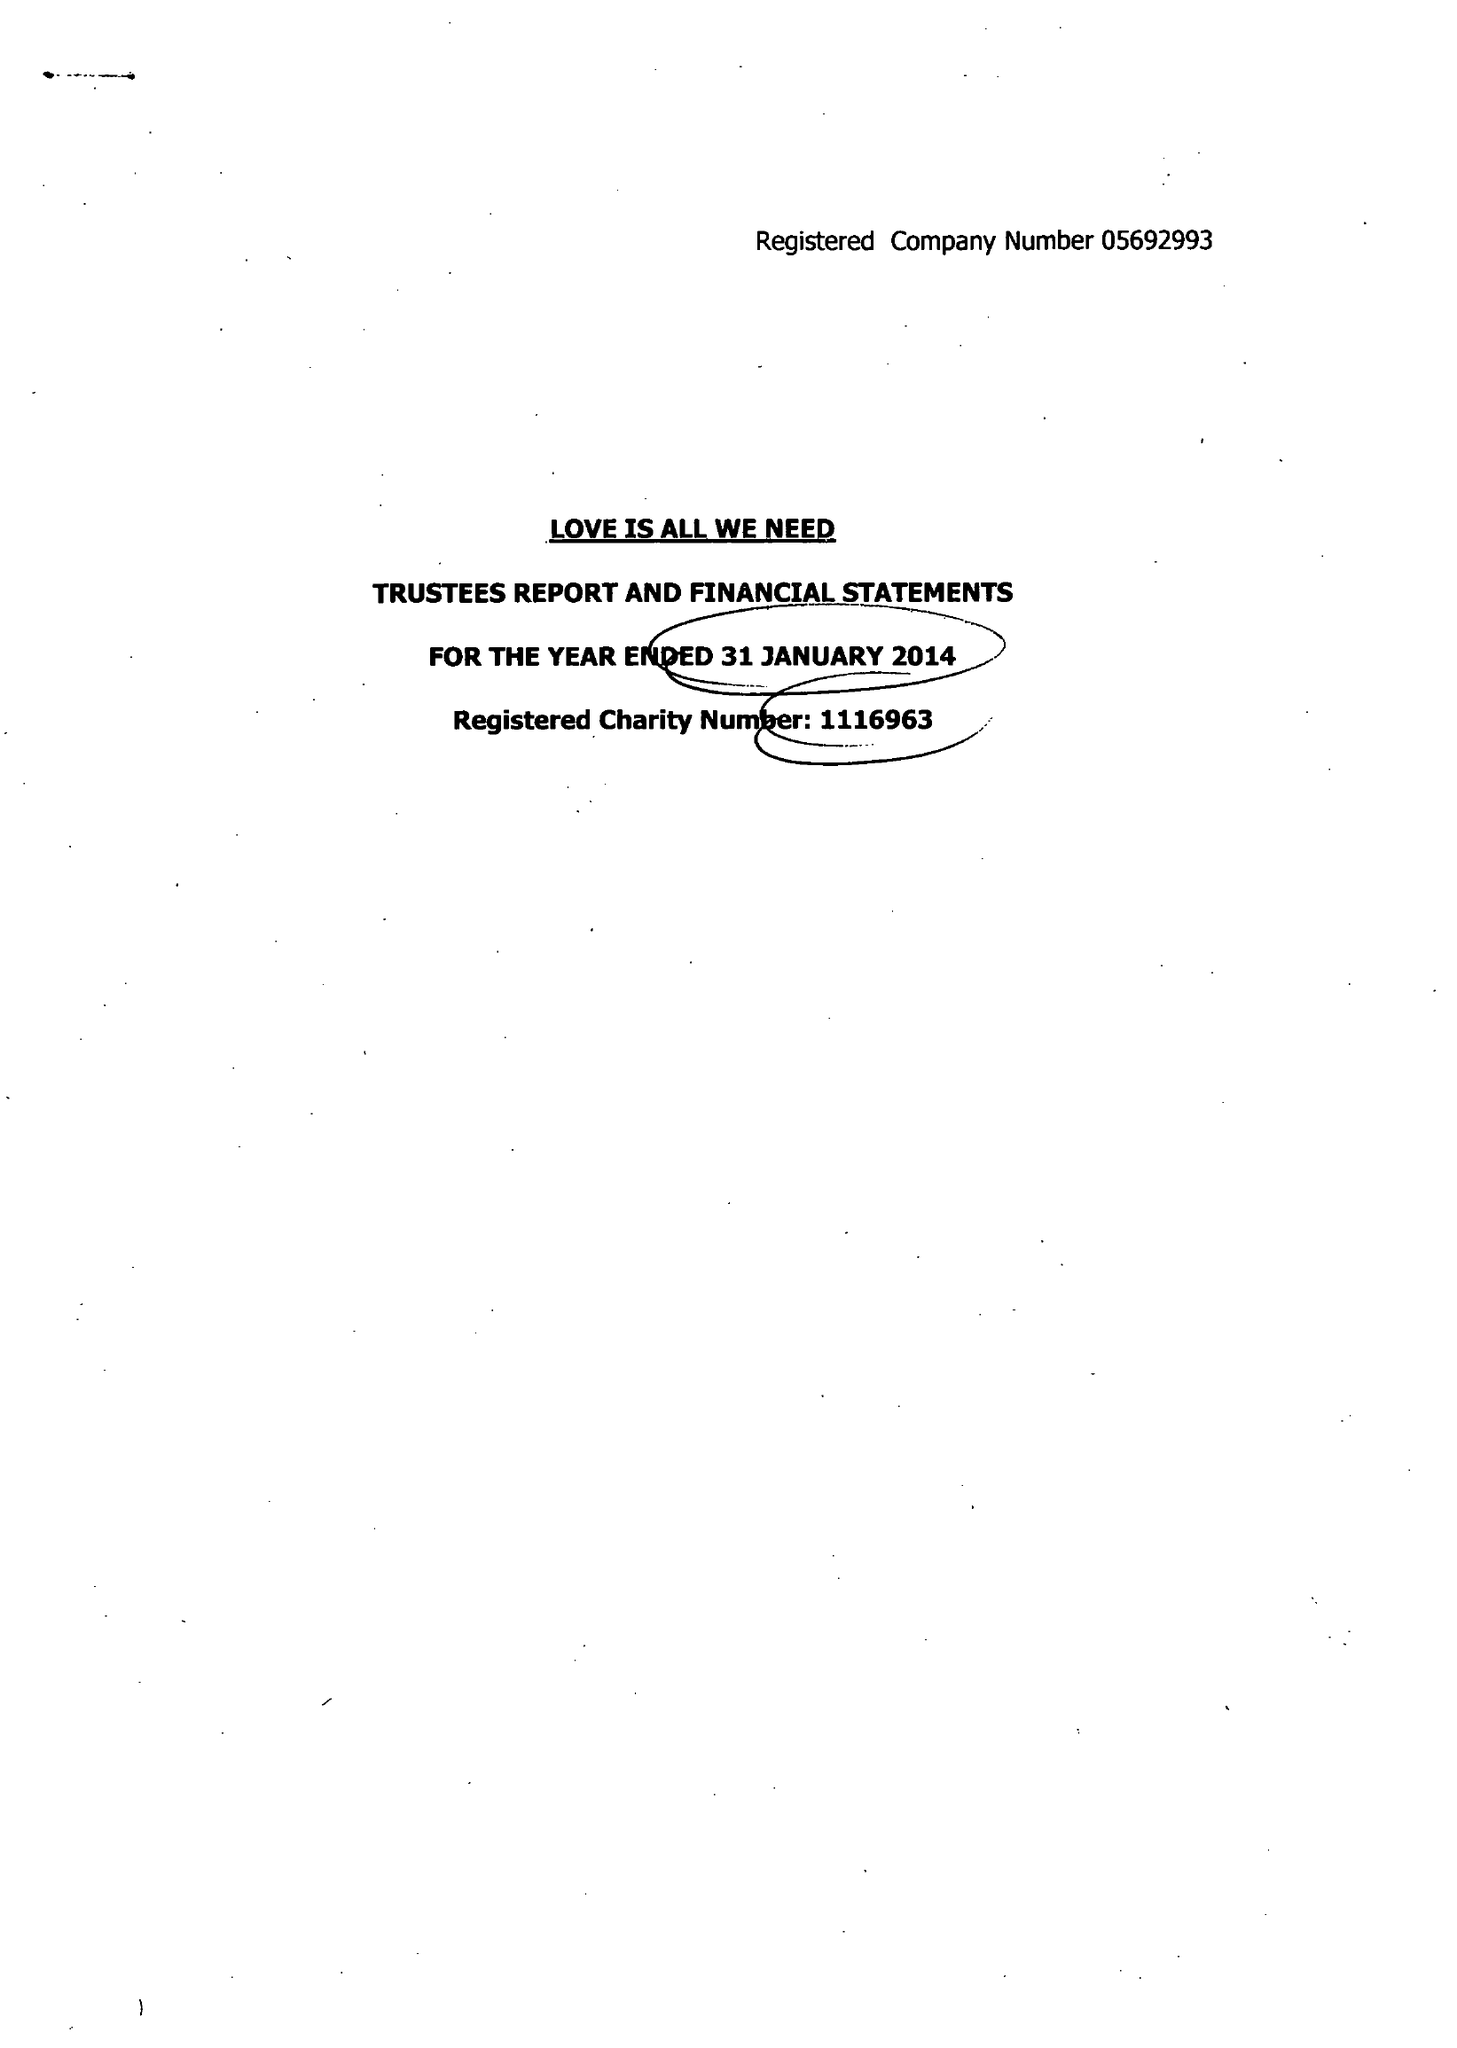What is the value for the spending_annually_in_british_pounds?
Answer the question using a single word or phrase. 25748.00 